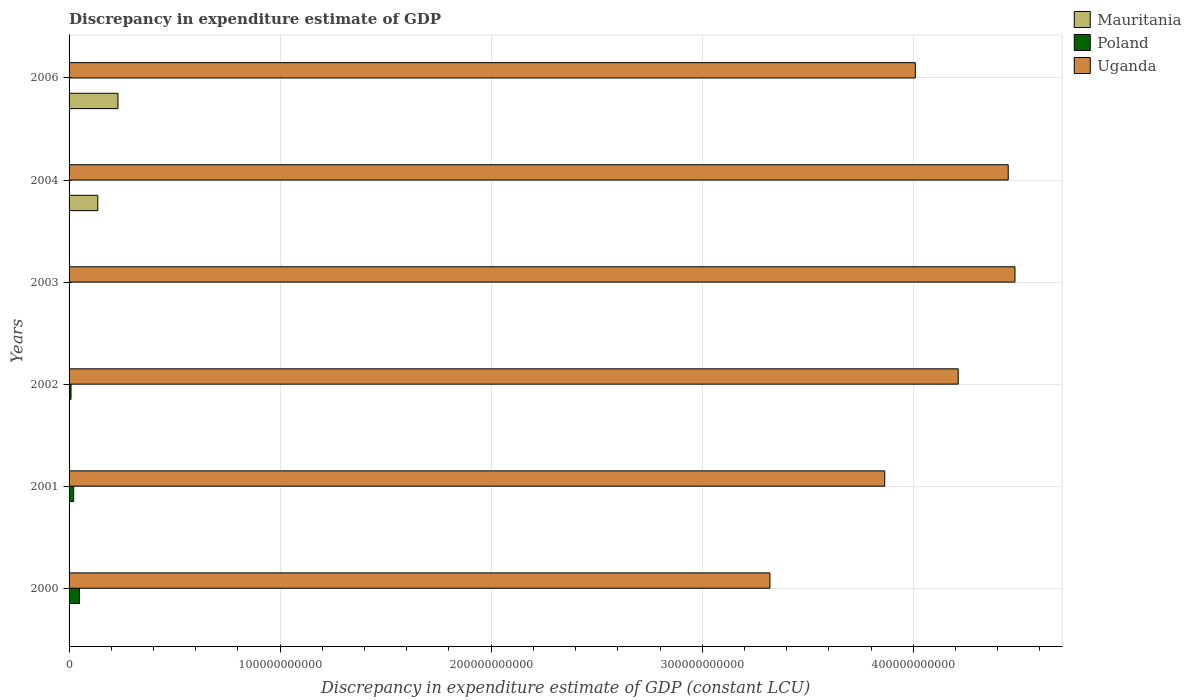How many different coloured bars are there?
Offer a very short reply. 3. Are the number of bars per tick equal to the number of legend labels?
Keep it short and to the point. No. Are the number of bars on each tick of the Y-axis equal?
Offer a terse response. No. How many bars are there on the 2nd tick from the top?
Give a very brief answer. 2. How many bars are there on the 2nd tick from the bottom?
Your answer should be compact. 2. What is the discrepancy in expenditure estimate of GDP in Uganda in 2006?
Provide a short and direct response. 4.01e+11. Across all years, what is the maximum discrepancy in expenditure estimate of GDP in Poland?
Your response must be concise. 4.93e+09. Across all years, what is the minimum discrepancy in expenditure estimate of GDP in Poland?
Ensure brevity in your answer.  0. In which year was the discrepancy in expenditure estimate of GDP in Poland maximum?
Provide a succinct answer. 2000. What is the total discrepancy in expenditure estimate of GDP in Mauritania in the graph?
Keep it short and to the point. 3.68e+1. What is the difference between the discrepancy in expenditure estimate of GDP in Uganda in 2000 and that in 2004?
Offer a terse response. -1.13e+11. What is the difference between the discrepancy in expenditure estimate of GDP in Uganda in 2006 and the discrepancy in expenditure estimate of GDP in Poland in 2002?
Give a very brief answer. 4.00e+11. What is the average discrepancy in expenditure estimate of GDP in Poland per year?
Offer a terse response. 1.34e+09. In the year 2006, what is the difference between the discrepancy in expenditure estimate of GDP in Mauritania and discrepancy in expenditure estimate of GDP in Uganda?
Keep it short and to the point. -3.78e+11. In how many years, is the discrepancy in expenditure estimate of GDP in Uganda greater than 240000000000 LCU?
Keep it short and to the point. 6. What is the ratio of the discrepancy in expenditure estimate of GDP in Uganda in 2001 to that in 2006?
Offer a very short reply. 0.96. Is the discrepancy in expenditure estimate of GDP in Uganda in 2000 less than that in 2004?
Ensure brevity in your answer.  Yes. What is the difference between the highest and the second highest discrepancy in expenditure estimate of GDP in Uganda?
Provide a succinct answer. 3.20e+09. What is the difference between the highest and the lowest discrepancy in expenditure estimate of GDP in Mauritania?
Offer a terse response. 2.32e+1. How many bars are there?
Your answer should be compact. 12. How many years are there in the graph?
Provide a succinct answer. 6. What is the difference between two consecutive major ticks on the X-axis?
Offer a terse response. 1.00e+11. How many legend labels are there?
Your answer should be very brief. 3. How are the legend labels stacked?
Provide a succinct answer. Vertical. What is the title of the graph?
Make the answer very short. Discrepancy in expenditure estimate of GDP. Does "Macao" appear as one of the legend labels in the graph?
Provide a succinct answer. No. What is the label or title of the X-axis?
Give a very brief answer. Discrepancy in expenditure estimate of GDP (constant LCU). What is the label or title of the Y-axis?
Your answer should be very brief. Years. What is the Discrepancy in expenditure estimate of GDP (constant LCU) of Mauritania in 2000?
Ensure brevity in your answer.  0. What is the Discrepancy in expenditure estimate of GDP (constant LCU) in Poland in 2000?
Provide a short and direct response. 4.93e+09. What is the Discrepancy in expenditure estimate of GDP (constant LCU) of Uganda in 2000?
Your response must be concise. 3.32e+11. What is the Discrepancy in expenditure estimate of GDP (constant LCU) of Mauritania in 2001?
Ensure brevity in your answer.  0. What is the Discrepancy in expenditure estimate of GDP (constant LCU) in Poland in 2001?
Give a very brief answer. 2.18e+09. What is the Discrepancy in expenditure estimate of GDP (constant LCU) of Uganda in 2001?
Your response must be concise. 3.86e+11. What is the Discrepancy in expenditure estimate of GDP (constant LCU) of Poland in 2002?
Make the answer very short. 9.20e+08. What is the Discrepancy in expenditure estimate of GDP (constant LCU) of Uganda in 2002?
Ensure brevity in your answer.  4.21e+11. What is the Discrepancy in expenditure estimate of GDP (constant LCU) in Mauritania in 2003?
Ensure brevity in your answer.  0. What is the Discrepancy in expenditure estimate of GDP (constant LCU) in Poland in 2003?
Provide a short and direct response. 0. What is the Discrepancy in expenditure estimate of GDP (constant LCU) in Uganda in 2003?
Provide a succinct answer. 4.48e+11. What is the Discrepancy in expenditure estimate of GDP (constant LCU) in Mauritania in 2004?
Your answer should be very brief. 1.36e+1. What is the Discrepancy in expenditure estimate of GDP (constant LCU) in Poland in 2004?
Give a very brief answer. 0. What is the Discrepancy in expenditure estimate of GDP (constant LCU) in Uganda in 2004?
Keep it short and to the point. 4.45e+11. What is the Discrepancy in expenditure estimate of GDP (constant LCU) in Mauritania in 2006?
Keep it short and to the point. 2.32e+1. What is the Discrepancy in expenditure estimate of GDP (constant LCU) of Poland in 2006?
Ensure brevity in your answer.  5.36e+05. What is the Discrepancy in expenditure estimate of GDP (constant LCU) in Uganda in 2006?
Provide a succinct answer. 4.01e+11. Across all years, what is the maximum Discrepancy in expenditure estimate of GDP (constant LCU) of Mauritania?
Provide a short and direct response. 2.32e+1. Across all years, what is the maximum Discrepancy in expenditure estimate of GDP (constant LCU) of Poland?
Offer a very short reply. 4.93e+09. Across all years, what is the maximum Discrepancy in expenditure estimate of GDP (constant LCU) in Uganda?
Give a very brief answer. 4.48e+11. Across all years, what is the minimum Discrepancy in expenditure estimate of GDP (constant LCU) in Uganda?
Ensure brevity in your answer.  3.32e+11. What is the total Discrepancy in expenditure estimate of GDP (constant LCU) of Mauritania in the graph?
Offer a very short reply. 3.68e+1. What is the total Discrepancy in expenditure estimate of GDP (constant LCU) of Poland in the graph?
Your answer should be very brief. 8.03e+09. What is the total Discrepancy in expenditure estimate of GDP (constant LCU) of Uganda in the graph?
Your answer should be very brief. 2.43e+12. What is the difference between the Discrepancy in expenditure estimate of GDP (constant LCU) in Poland in 2000 and that in 2001?
Give a very brief answer. 2.75e+09. What is the difference between the Discrepancy in expenditure estimate of GDP (constant LCU) of Uganda in 2000 and that in 2001?
Give a very brief answer. -5.44e+1. What is the difference between the Discrepancy in expenditure estimate of GDP (constant LCU) of Poland in 2000 and that in 2002?
Your response must be concise. 4.01e+09. What is the difference between the Discrepancy in expenditure estimate of GDP (constant LCU) in Uganda in 2000 and that in 2002?
Ensure brevity in your answer.  -8.92e+1. What is the difference between the Discrepancy in expenditure estimate of GDP (constant LCU) of Uganda in 2000 and that in 2003?
Your answer should be very brief. -1.16e+11. What is the difference between the Discrepancy in expenditure estimate of GDP (constant LCU) of Uganda in 2000 and that in 2004?
Offer a terse response. -1.13e+11. What is the difference between the Discrepancy in expenditure estimate of GDP (constant LCU) in Poland in 2000 and that in 2006?
Your response must be concise. 4.93e+09. What is the difference between the Discrepancy in expenditure estimate of GDP (constant LCU) of Uganda in 2000 and that in 2006?
Provide a short and direct response. -6.89e+1. What is the difference between the Discrepancy in expenditure estimate of GDP (constant LCU) of Poland in 2001 and that in 2002?
Offer a very short reply. 1.26e+09. What is the difference between the Discrepancy in expenditure estimate of GDP (constant LCU) in Uganda in 2001 and that in 2002?
Your response must be concise. -3.48e+1. What is the difference between the Discrepancy in expenditure estimate of GDP (constant LCU) in Uganda in 2001 and that in 2003?
Your answer should be compact. -6.17e+1. What is the difference between the Discrepancy in expenditure estimate of GDP (constant LCU) in Uganda in 2001 and that in 2004?
Ensure brevity in your answer.  -5.85e+1. What is the difference between the Discrepancy in expenditure estimate of GDP (constant LCU) in Poland in 2001 and that in 2006?
Offer a terse response. 2.18e+09. What is the difference between the Discrepancy in expenditure estimate of GDP (constant LCU) in Uganda in 2001 and that in 2006?
Your answer should be very brief. -1.45e+1. What is the difference between the Discrepancy in expenditure estimate of GDP (constant LCU) in Uganda in 2002 and that in 2003?
Make the answer very short. -2.69e+1. What is the difference between the Discrepancy in expenditure estimate of GDP (constant LCU) of Uganda in 2002 and that in 2004?
Your answer should be compact. -2.37e+1. What is the difference between the Discrepancy in expenditure estimate of GDP (constant LCU) in Poland in 2002 and that in 2006?
Offer a terse response. 9.19e+08. What is the difference between the Discrepancy in expenditure estimate of GDP (constant LCU) of Uganda in 2002 and that in 2006?
Your response must be concise. 2.03e+1. What is the difference between the Discrepancy in expenditure estimate of GDP (constant LCU) in Uganda in 2003 and that in 2004?
Offer a terse response. 3.20e+09. What is the difference between the Discrepancy in expenditure estimate of GDP (constant LCU) of Uganda in 2003 and that in 2006?
Offer a terse response. 4.72e+1. What is the difference between the Discrepancy in expenditure estimate of GDP (constant LCU) in Mauritania in 2004 and that in 2006?
Your response must be concise. -9.56e+09. What is the difference between the Discrepancy in expenditure estimate of GDP (constant LCU) in Uganda in 2004 and that in 2006?
Your response must be concise. 4.40e+1. What is the difference between the Discrepancy in expenditure estimate of GDP (constant LCU) of Poland in 2000 and the Discrepancy in expenditure estimate of GDP (constant LCU) of Uganda in 2001?
Give a very brief answer. -3.82e+11. What is the difference between the Discrepancy in expenditure estimate of GDP (constant LCU) of Poland in 2000 and the Discrepancy in expenditure estimate of GDP (constant LCU) of Uganda in 2002?
Provide a short and direct response. -4.16e+11. What is the difference between the Discrepancy in expenditure estimate of GDP (constant LCU) of Poland in 2000 and the Discrepancy in expenditure estimate of GDP (constant LCU) of Uganda in 2003?
Provide a succinct answer. -4.43e+11. What is the difference between the Discrepancy in expenditure estimate of GDP (constant LCU) in Poland in 2000 and the Discrepancy in expenditure estimate of GDP (constant LCU) in Uganda in 2004?
Ensure brevity in your answer.  -4.40e+11. What is the difference between the Discrepancy in expenditure estimate of GDP (constant LCU) of Poland in 2000 and the Discrepancy in expenditure estimate of GDP (constant LCU) of Uganda in 2006?
Offer a very short reply. -3.96e+11. What is the difference between the Discrepancy in expenditure estimate of GDP (constant LCU) in Poland in 2001 and the Discrepancy in expenditure estimate of GDP (constant LCU) in Uganda in 2002?
Give a very brief answer. -4.19e+11. What is the difference between the Discrepancy in expenditure estimate of GDP (constant LCU) of Poland in 2001 and the Discrepancy in expenditure estimate of GDP (constant LCU) of Uganda in 2003?
Provide a succinct answer. -4.46e+11. What is the difference between the Discrepancy in expenditure estimate of GDP (constant LCU) in Poland in 2001 and the Discrepancy in expenditure estimate of GDP (constant LCU) in Uganda in 2004?
Offer a terse response. -4.43e+11. What is the difference between the Discrepancy in expenditure estimate of GDP (constant LCU) in Poland in 2001 and the Discrepancy in expenditure estimate of GDP (constant LCU) in Uganda in 2006?
Give a very brief answer. -3.99e+11. What is the difference between the Discrepancy in expenditure estimate of GDP (constant LCU) in Poland in 2002 and the Discrepancy in expenditure estimate of GDP (constant LCU) in Uganda in 2003?
Ensure brevity in your answer.  -4.47e+11. What is the difference between the Discrepancy in expenditure estimate of GDP (constant LCU) of Poland in 2002 and the Discrepancy in expenditure estimate of GDP (constant LCU) of Uganda in 2004?
Your response must be concise. -4.44e+11. What is the difference between the Discrepancy in expenditure estimate of GDP (constant LCU) of Poland in 2002 and the Discrepancy in expenditure estimate of GDP (constant LCU) of Uganda in 2006?
Offer a terse response. -4.00e+11. What is the difference between the Discrepancy in expenditure estimate of GDP (constant LCU) of Mauritania in 2004 and the Discrepancy in expenditure estimate of GDP (constant LCU) of Poland in 2006?
Offer a terse response. 1.36e+1. What is the difference between the Discrepancy in expenditure estimate of GDP (constant LCU) of Mauritania in 2004 and the Discrepancy in expenditure estimate of GDP (constant LCU) of Uganda in 2006?
Make the answer very short. -3.87e+11. What is the average Discrepancy in expenditure estimate of GDP (constant LCU) of Mauritania per year?
Ensure brevity in your answer.  6.13e+09. What is the average Discrepancy in expenditure estimate of GDP (constant LCU) in Poland per year?
Provide a succinct answer. 1.34e+09. What is the average Discrepancy in expenditure estimate of GDP (constant LCU) in Uganda per year?
Provide a short and direct response. 4.06e+11. In the year 2000, what is the difference between the Discrepancy in expenditure estimate of GDP (constant LCU) in Poland and Discrepancy in expenditure estimate of GDP (constant LCU) in Uganda?
Your response must be concise. -3.27e+11. In the year 2001, what is the difference between the Discrepancy in expenditure estimate of GDP (constant LCU) of Poland and Discrepancy in expenditure estimate of GDP (constant LCU) of Uganda?
Your response must be concise. -3.84e+11. In the year 2002, what is the difference between the Discrepancy in expenditure estimate of GDP (constant LCU) of Poland and Discrepancy in expenditure estimate of GDP (constant LCU) of Uganda?
Give a very brief answer. -4.20e+11. In the year 2004, what is the difference between the Discrepancy in expenditure estimate of GDP (constant LCU) of Mauritania and Discrepancy in expenditure estimate of GDP (constant LCU) of Uganda?
Give a very brief answer. -4.31e+11. In the year 2006, what is the difference between the Discrepancy in expenditure estimate of GDP (constant LCU) in Mauritania and Discrepancy in expenditure estimate of GDP (constant LCU) in Poland?
Your answer should be compact. 2.32e+1. In the year 2006, what is the difference between the Discrepancy in expenditure estimate of GDP (constant LCU) in Mauritania and Discrepancy in expenditure estimate of GDP (constant LCU) in Uganda?
Offer a terse response. -3.78e+11. In the year 2006, what is the difference between the Discrepancy in expenditure estimate of GDP (constant LCU) of Poland and Discrepancy in expenditure estimate of GDP (constant LCU) of Uganda?
Make the answer very short. -4.01e+11. What is the ratio of the Discrepancy in expenditure estimate of GDP (constant LCU) of Poland in 2000 to that in 2001?
Offer a terse response. 2.26. What is the ratio of the Discrepancy in expenditure estimate of GDP (constant LCU) in Uganda in 2000 to that in 2001?
Keep it short and to the point. 0.86. What is the ratio of the Discrepancy in expenditure estimate of GDP (constant LCU) of Poland in 2000 to that in 2002?
Ensure brevity in your answer.  5.36. What is the ratio of the Discrepancy in expenditure estimate of GDP (constant LCU) of Uganda in 2000 to that in 2002?
Provide a short and direct response. 0.79. What is the ratio of the Discrepancy in expenditure estimate of GDP (constant LCU) of Uganda in 2000 to that in 2003?
Give a very brief answer. 0.74. What is the ratio of the Discrepancy in expenditure estimate of GDP (constant LCU) of Uganda in 2000 to that in 2004?
Provide a succinct answer. 0.75. What is the ratio of the Discrepancy in expenditure estimate of GDP (constant LCU) in Poland in 2000 to that in 2006?
Ensure brevity in your answer.  9203.85. What is the ratio of the Discrepancy in expenditure estimate of GDP (constant LCU) in Uganda in 2000 to that in 2006?
Your answer should be compact. 0.83. What is the ratio of the Discrepancy in expenditure estimate of GDP (constant LCU) in Poland in 2001 to that in 2002?
Make the answer very short. 2.37. What is the ratio of the Discrepancy in expenditure estimate of GDP (constant LCU) of Uganda in 2001 to that in 2002?
Provide a succinct answer. 0.92. What is the ratio of the Discrepancy in expenditure estimate of GDP (constant LCU) of Uganda in 2001 to that in 2003?
Provide a short and direct response. 0.86. What is the ratio of the Discrepancy in expenditure estimate of GDP (constant LCU) in Uganda in 2001 to that in 2004?
Ensure brevity in your answer.  0.87. What is the ratio of the Discrepancy in expenditure estimate of GDP (constant LCU) in Poland in 2001 to that in 2006?
Provide a succinct answer. 4073.17. What is the ratio of the Discrepancy in expenditure estimate of GDP (constant LCU) in Uganda in 2001 to that in 2006?
Provide a short and direct response. 0.96. What is the ratio of the Discrepancy in expenditure estimate of GDP (constant LCU) of Uganda in 2002 to that in 2003?
Offer a very short reply. 0.94. What is the ratio of the Discrepancy in expenditure estimate of GDP (constant LCU) in Uganda in 2002 to that in 2004?
Keep it short and to the point. 0.95. What is the ratio of the Discrepancy in expenditure estimate of GDP (constant LCU) in Poland in 2002 to that in 2006?
Make the answer very short. 1717.47. What is the ratio of the Discrepancy in expenditure estimate of GDP (constant LCU) of Uganda in 2002 to that in 2006?
Your answer should be compact. 1.05. What is the ratio of the Discrepancy in expenditure estimate of GDP (constant LCU) in Uganda in 2003 to that in 2004?
Give a very brief answer. 1.01. What is the ratio of the Discrepancy in expenditure estimate of GDP (constant LCU) of Uganda in 2003 to that in 2006?
Offer a very short reply. 1.12. What is the ratio of the Discrepancy in expenditure estimate of GDP (constant LCU) of Mauritania in 2004 to that in 2006?
Your answer should be compact. 0.59. What is the ratio of the Discrepancy in expenditure estimate of GDP (constant LCU) in Uganda in 2004 to that in 2006?
Offer a terse response. 1.11. What is the difference between the highest and the second highest Discrepancy in expenditure estimate of GDP (constant LCU) of Poland?
Your answer should be very brief. 2.75e+09. What is the difference between the highest and the second highest Discrepancy in expenditure estimate of GDP (constant LCU) of Uganda?
Your response must be concise. 3.20e+09. What is the difference between the highest and the lowest Discrepancy in expenditure estimate of GDP (constant LCU) in Mauritania?
Make the answer very short. 2.32e+1. What is the difference between the highest and the lowest Discrepancy in expenditure estimate of GDP (constant LCU) in Poland?
Make the answer very short. 4.93e+09. What is the difference between the highest and the lowest Discrepancy in expenditure estimate of GDP (constant LCU) in Uganda?
Offer a very short reply. 1.16e+11. 